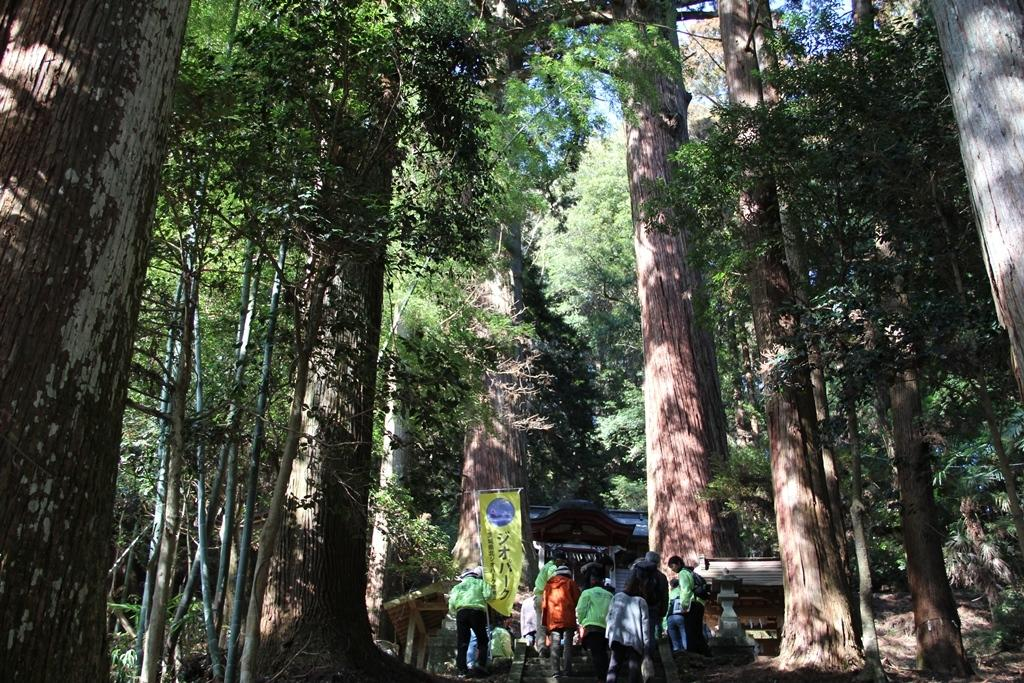What is the main subject of the image? The main subject of the image is a group of people standing. What else can be seen in the image besides the people? There is a flex banner and a house in the image. What is visible in the background of the image? Trees and the sky are visible in the background of the image. What type of toy can be seen in the hands of the people in the image? There is no toy visible in the hands of the people in the image. What is the purpose of the quince in the image? There is no quince present in the image. 